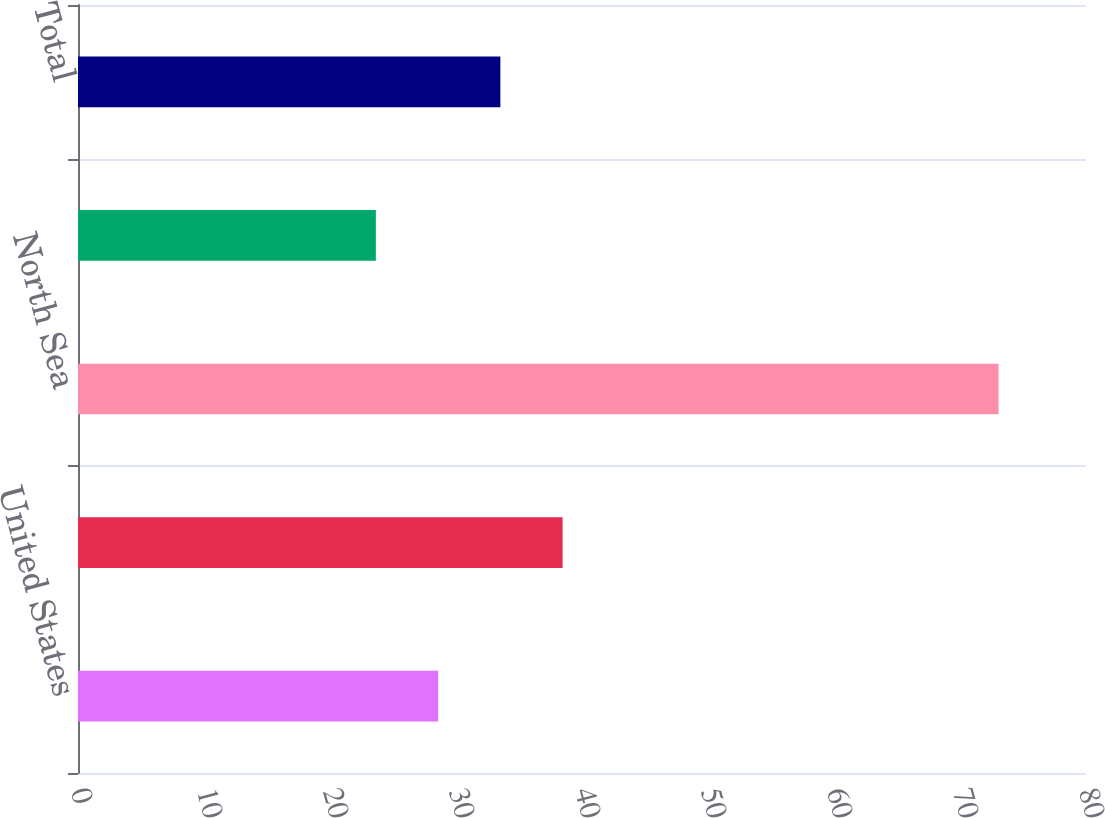<chart> <loc_0><loc_0><loc_500><loc_500><bar_chart><fcel>United States<fcel>Canada<fcel>North Sea<fcel>Argentina<fcel>Total<nl><fcel>28.58<fcel>38.46<fcel>73.06<fcel>23.64<fcel>33.52<nl></chart> 